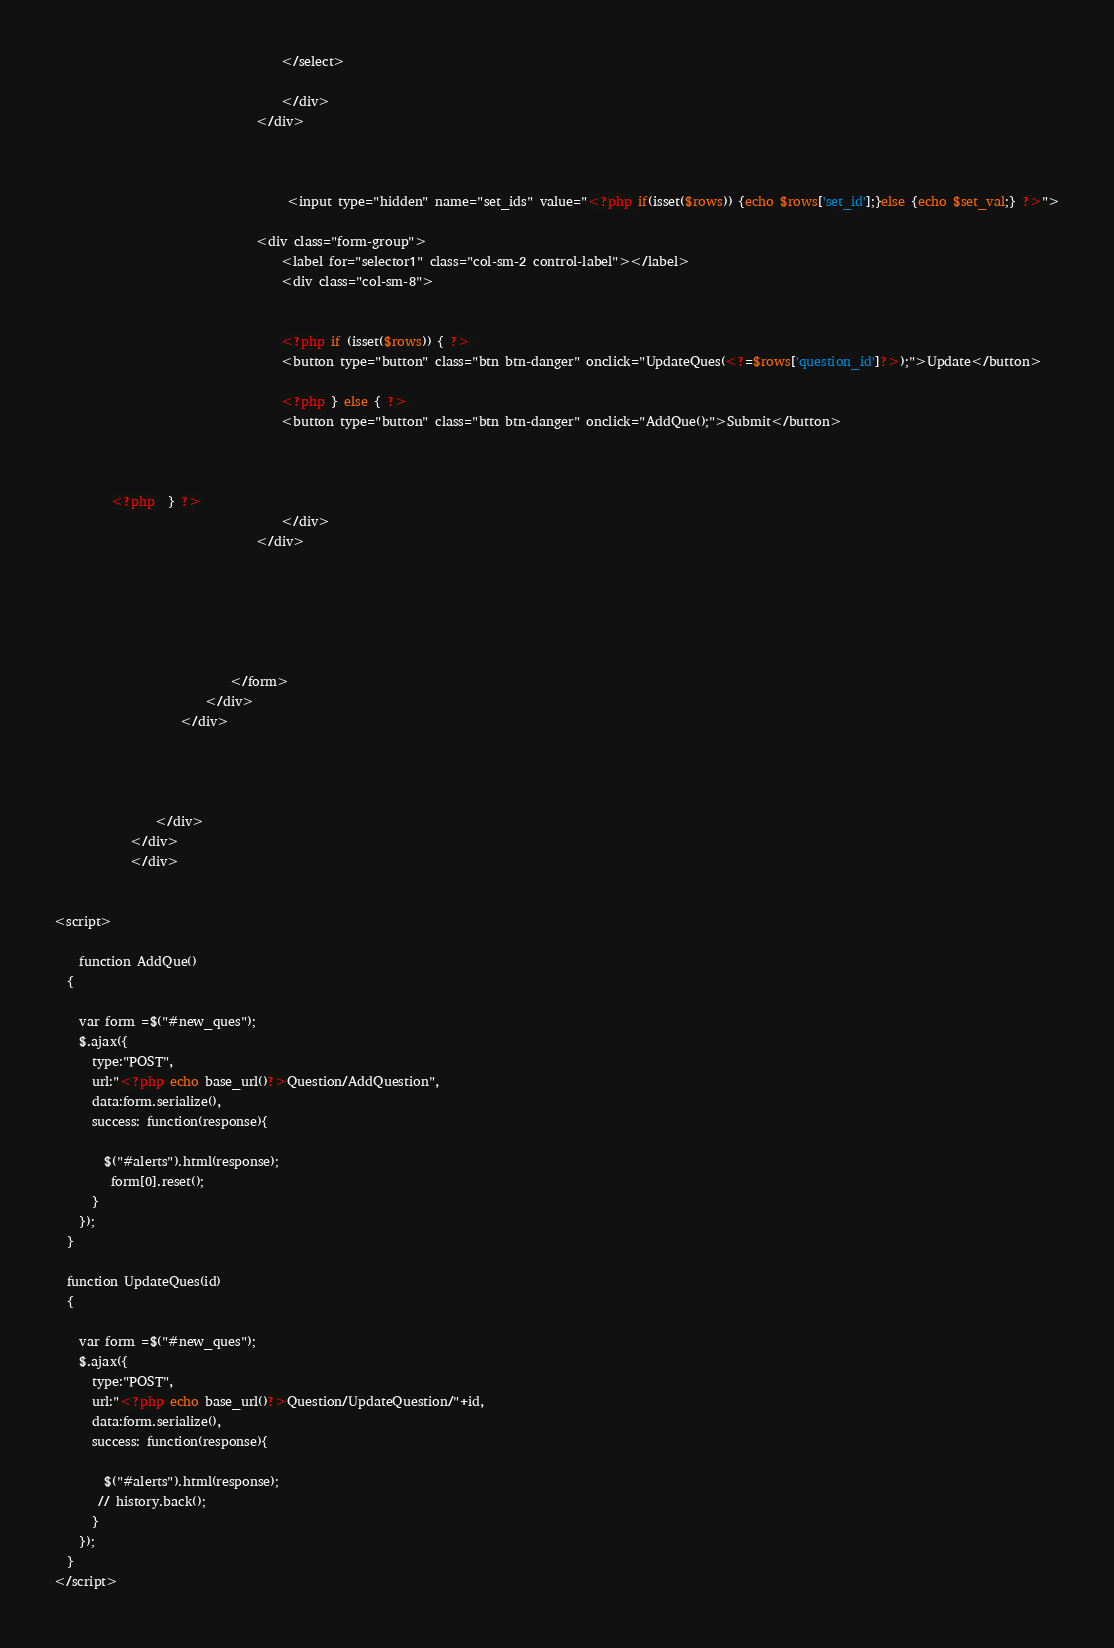Convert code to text. <code><loc_0><loc_0><loc_500><loc_500><_PHP_>									</select>
									
									</div>
								</div>

										
									
									 <input type="hidden" name="set_ids" value="<?php if(isset($rows)) {echo $rows['set_id'];}else {echo $set_val;} ?>">

								<div class="form-group">
									<label for="selector1" class="col-sm-2 control-label"></label>
									<div class="col-sm-8">
									

									<?php if (isset($rows)) { ?>
           							<button type="button" class="btn btn-danger" onclick="UpdateQues(<?=$rows['question_id']?>);">Update</button> 

          							<?php } else { ?>
         							<button type="button" class="btn btn-danger" onclick="AddQue();">Submit</button>
           

                      
         <?php  } ?>
									</div>
								</div>
								
								
								
								
								
								
							</form>
						</div>
					</div>
					
					
  
						
				</div>
			</div>
			</div>


<script>
	
	function AddQue()
  {

    var form =$("#new_ques");
    $.ajax({
      type:"POST",
      url:"<?php echo base_url()?>Question/AddQuestion",
      data:form.serialize(),
      success: function(response){

        $("#alerts").html(response);
         form[0].reset();
      }
    });
  }

  function UpdateQues(id)
  {
  	
    var form =$("#new_ques");
    $.ajax({
      type:"POST",
      url:"<?php echo base_url()?>Question/UpdateQuestion/"+id,
      data:form.serialize(),
      success: function(response){

        $("#alerts").html(response);
       // history.back();
      }
    });
  }
</script></code> 